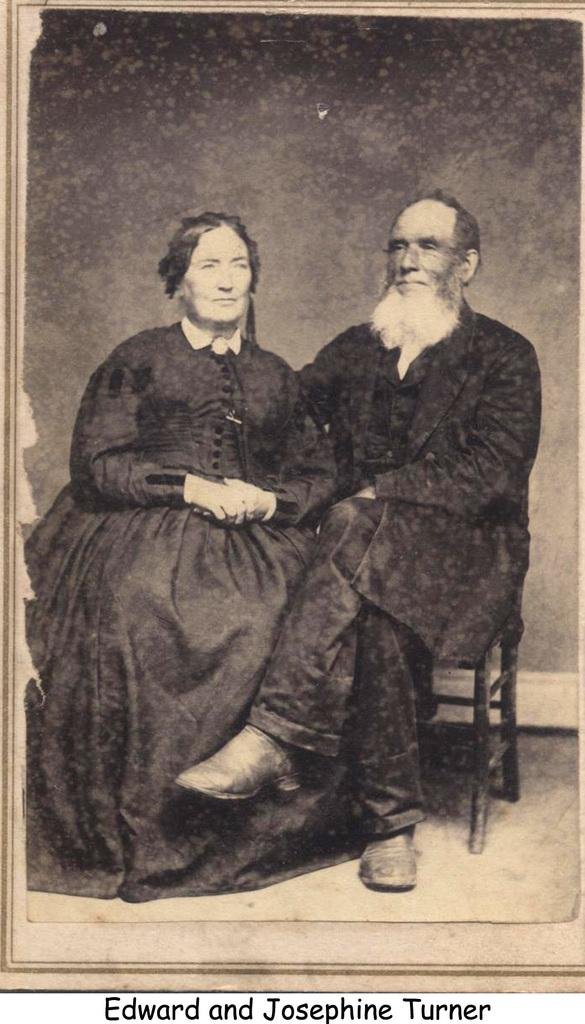What is the color scheme of the image? The image is black and white. Can you describe the people in the image? There is a man and a woman in the image, and both are sitting on chairs. What is the purpose of the chairs in the image? The chairs are likely for sitting and provide a place for the man and woman to rest. Is there any additional information or markings on the image? Yes, there is a watermark on the image. How many fairies are dancing around the man and woman in the image? There are no fairies present in the image; it only features a man and a woman sitting on chairs. What time of day is depicted in the image? The image is black and white, so it is not possible to determine the time of day from the image itself. 